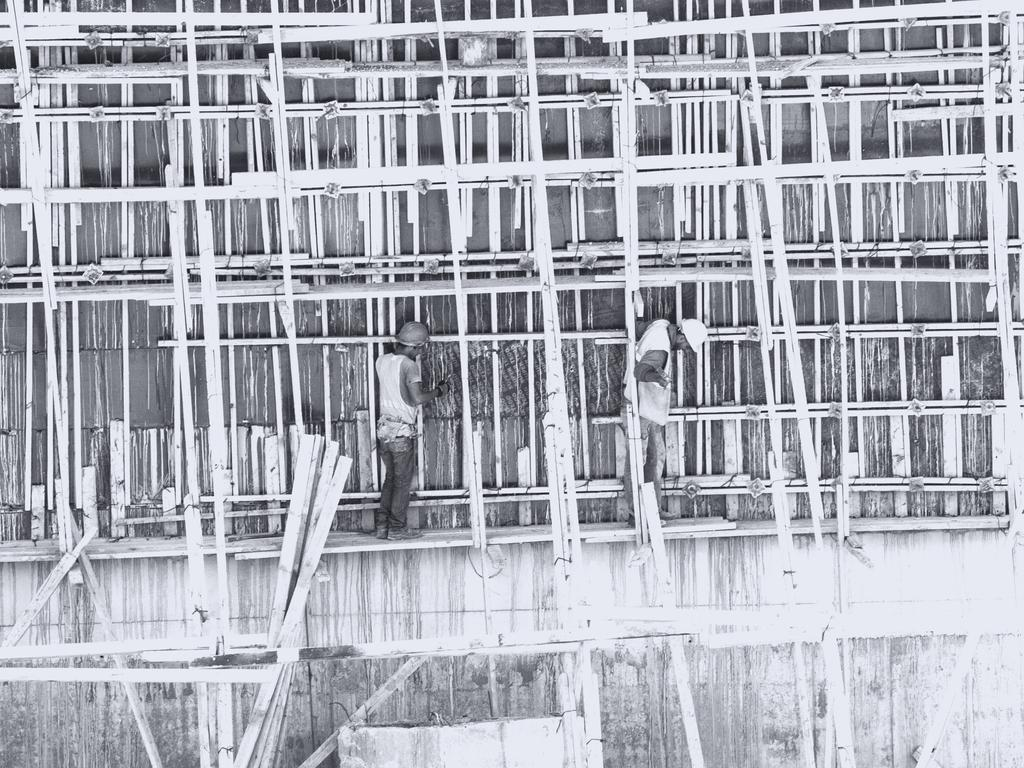What is the color scheme of the image? The image is black and white. How many people are in the image? There are two people in the image. What are the people standing on? The people are standing on a wooden object. What can be seen in the background of the image? There are wooden objects and a wall in the background of the image. What type of creature is crawling on the wall in the image? There is no creature visible on the wall in the image; it is a black and white image with two people standing on a wooden object and a wall in the background. 